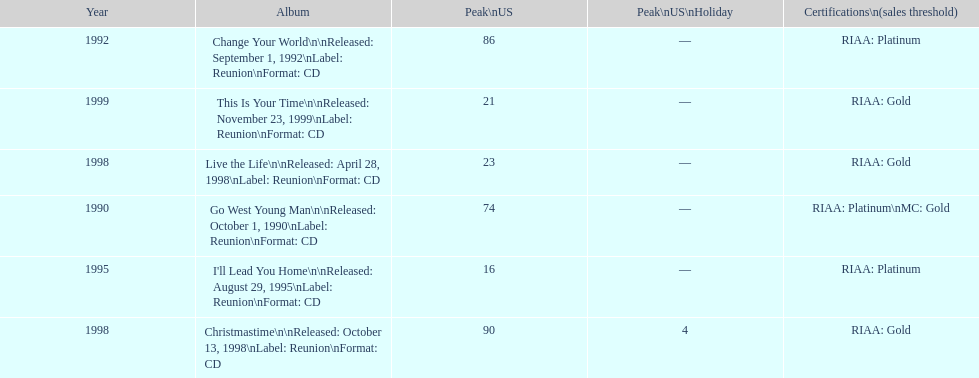What year comes after 1995? 1998. 